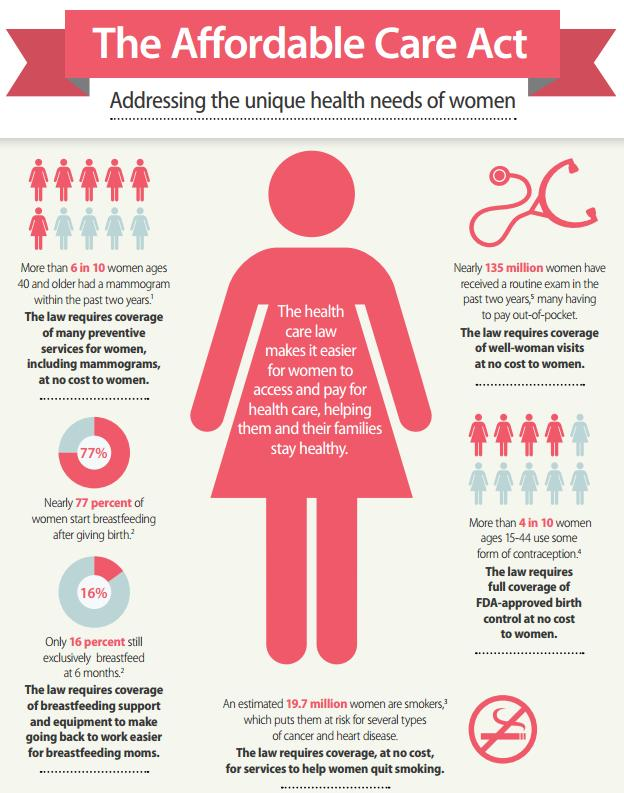Mention a couple of crucial points in this snapshot. According to a recent survey, 84% of women do not necessarily breastfeed after 6 months. 